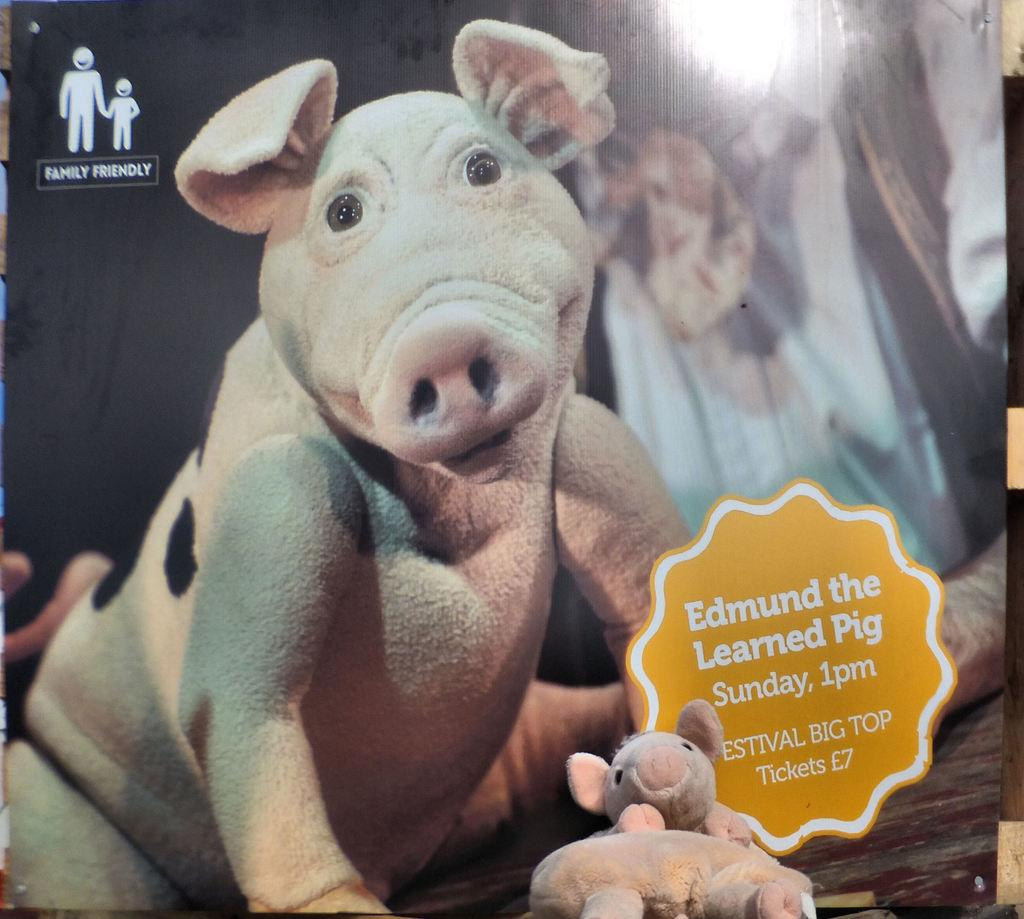What is present on the wall in the image? There is a poster in the image. What else can be seen in the image besides the poster? There are toys in the image. What is depicted on the poster? The poster contains an image of an animal. Is there any text on the poster? Yes, the poster contains some text. What type of juice is being served in the image? There is no juice present in the image; it features a poster with an animal image and toys. Can you tell me how many grandfathers are visible in the image? There are no grandfathers present in the image. 